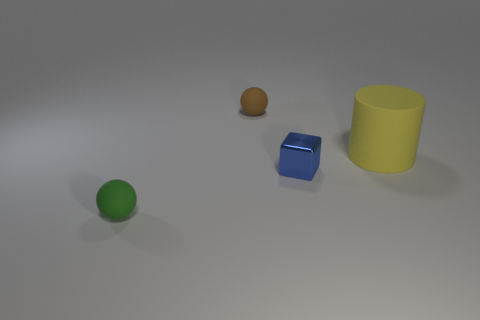There is another rubber object that is the same shape as the small brown matte thing; what is its size?
Give a very brief answer. Small. What is the shape of the small blue thing?
Provide a succinct answer. Cube. Does the big yellow cylinder have the same material as the thing that is in front of the small shiny object?
Your answer should be very brief. Yes. What number of shiny objects are either large things or tiny red objects?
Provide a short and direct response. 0. There is a matte object that is behind the large thing; what size is it?
Offer a terse response. Small. There is a yellow object that is the same material as the tiny green sphere; what is its size?
Keep it short and to the point. Large. What number of other small metal blocks are the same color as the small block?
Offer a terse response. 0. Are any yellow matte cylinders visible?
Your answer should be compact. Yes. There is a small shiny object; is it the same shape as the small rubber object that is behind the green matte sphere?
Provide a short and direct response. No. The ball that is in front of the tiny rubber object on the right side of the rubber ball in front of the big matte object is what color?
Provide a succinct answer. Green. 